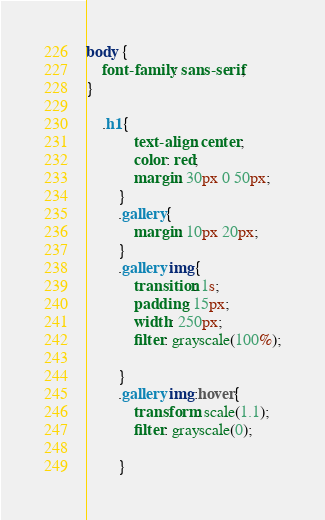<code> <loc_0><loc_0><loc_500><loc_500><_CSS_>body {
    font-family: sans-serif;
}

	.h1{
            text-align: center;
            color: red;
            margin: 30px 0 50px;
        }
        .gallery{
            margin: 10px 20px;
        }
        .gallery img{
            transition: 1s;
            padding: 15px;
            width: 250px;
            filter: grayscale(100%);

        }
        .gallery img:hover{
            transform: scale(1.1);
            filter: grayscale(0);

        }
</code> 